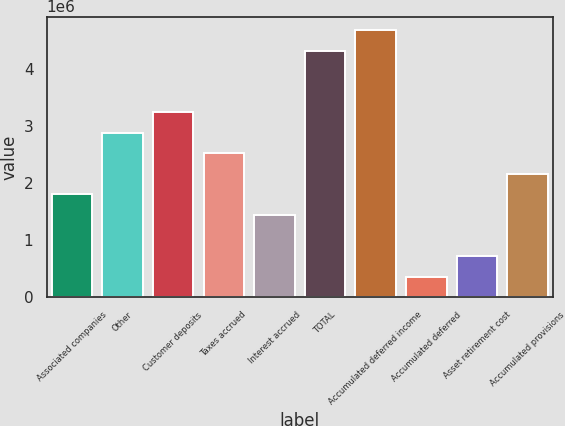Convert chart to OTSL. <chart><loc_0><loc_0><loc_500><loc_500><bar_chart><fcel>Associated companies<fcel>Other<fcel>Customer deposits<fcel>Taxes accrued<fcel>Interest accrued<fcel>TOTAL<fcel>Accumulated deferred income<fcel>Accumulated deferred<fcel>Asset retirement cost<fcel>Accumulated provisions<nl><fcel>1.80115e+06<fcel>2.88175e+06<fcel>3.24194e+06<fcel>2.52155e+06<fcel>1.44096e+06<fcel>4.32253e+06<fcel>4.68273e+06<fcel>360364<fcel>720562<fcel>2.16135e+06<nl></chart> 